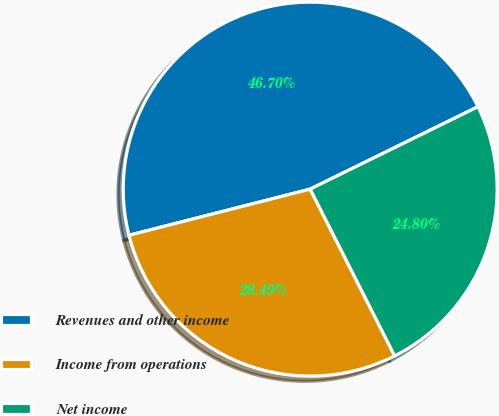<chart> <loc_0><loc_0><loc_500><loc_500><pie_chart><fcel>Revenues and other income<fcel>Income from operations<fcel>Net income<nl><fcel>46.7%<fcel>28.49%<fcel>24.8%<nl></chart> 